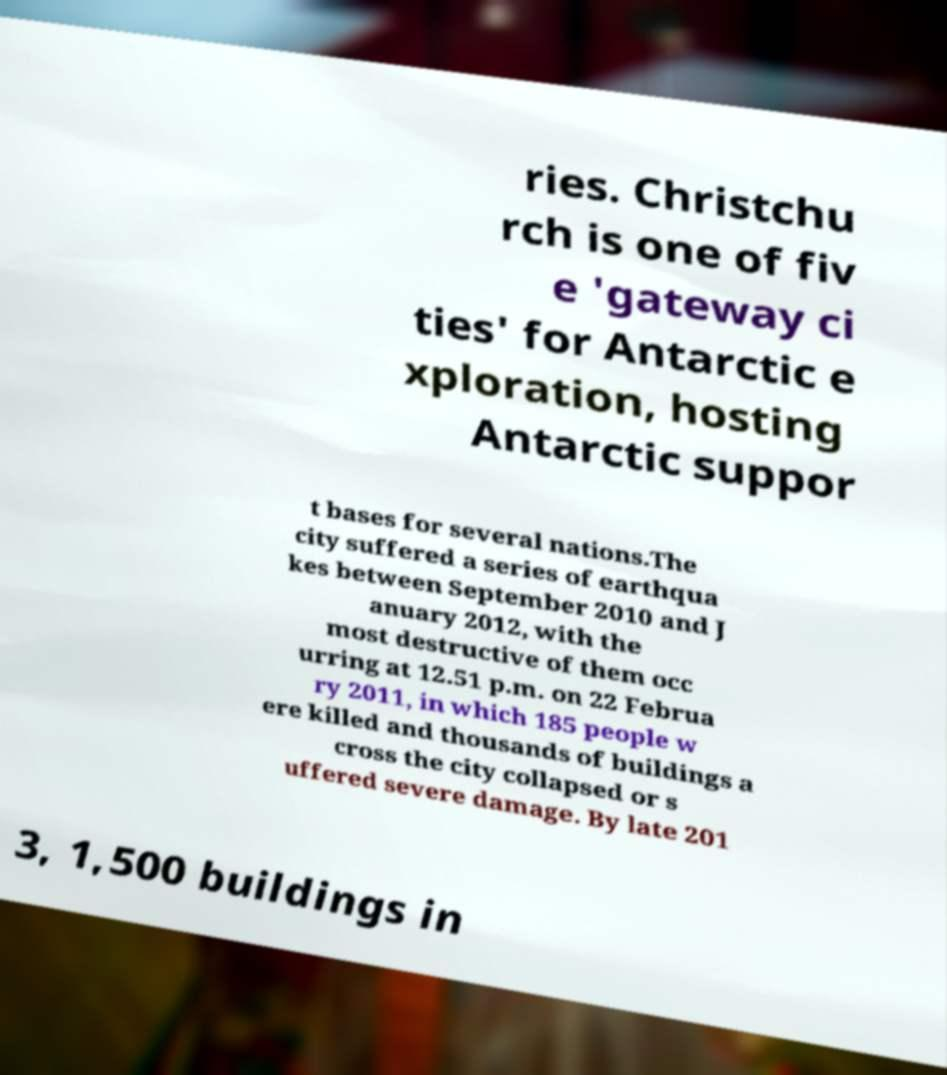Can you accurately transcribe the text from the provided image for me? ries. Christchu rch is one of fiv e 'gateway ci ties' for Antarctic e xploration, hosting Antarctic suppor t bases for several nations.The city suffered a series of earthqua kes between September 2010 and J anuary 2012, with the most destructive of them occ urring at 12.51 p.m. on 22 Februa ry 2011, in which 185 people w ere killed and thousands of buildings a cross the city collapsed or s uffered severe damage. By late 201 3, 1,500 buildings in 